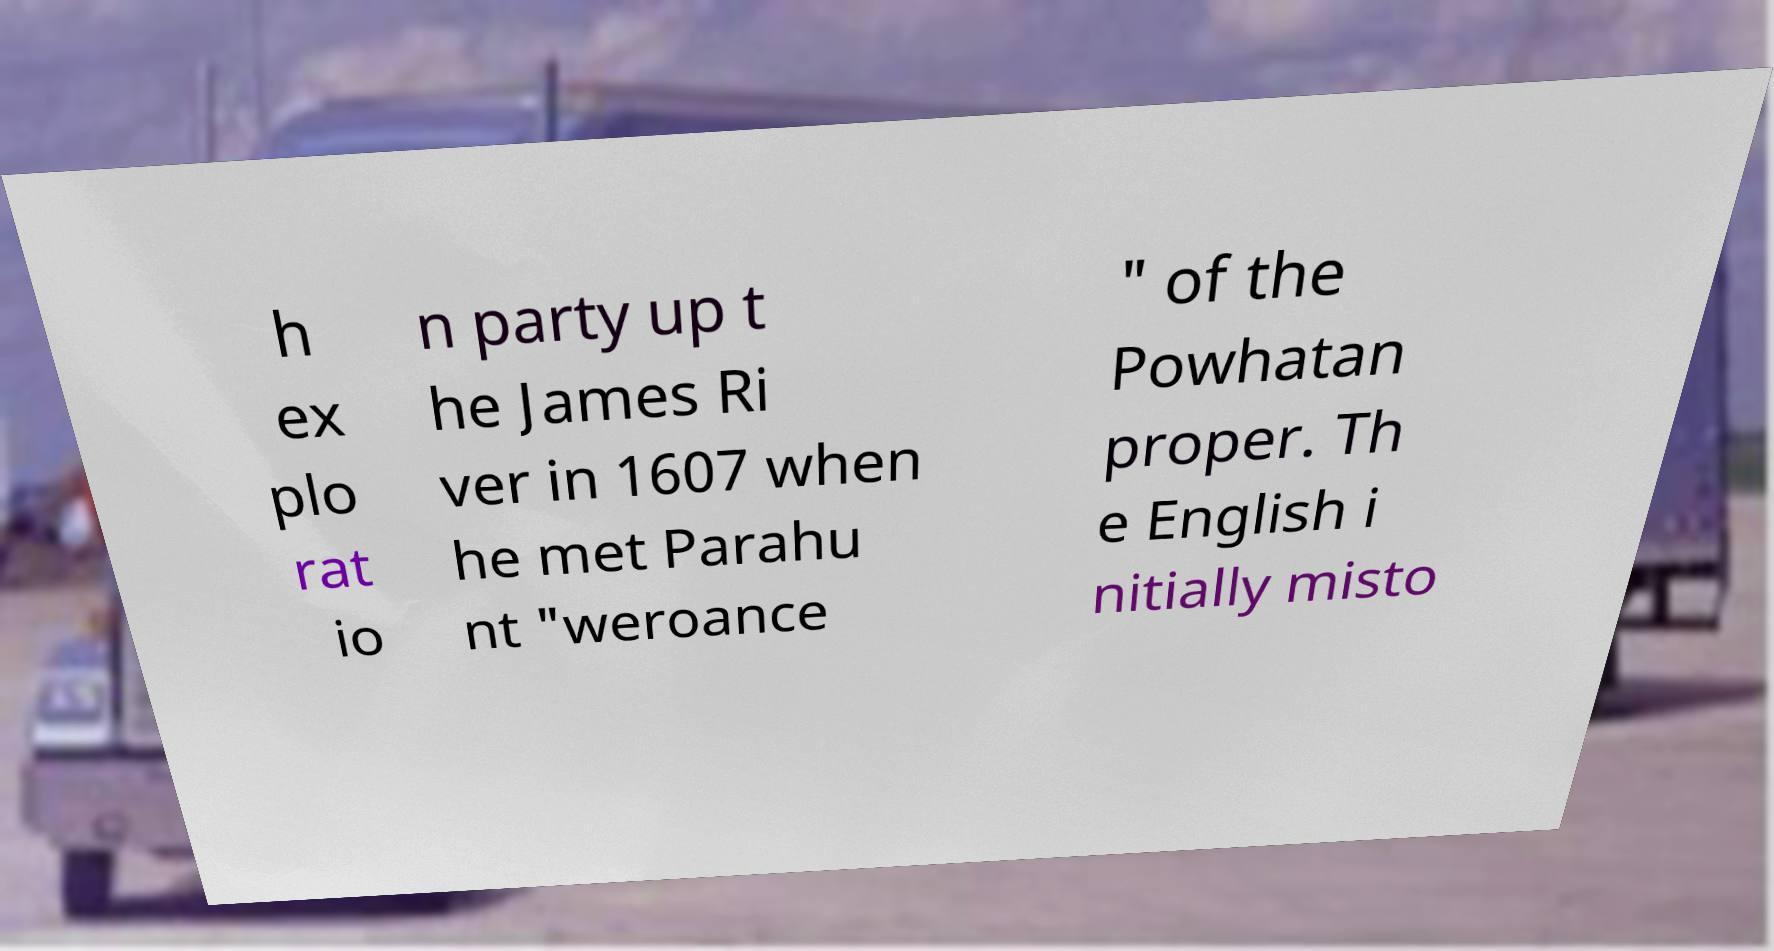Please read and relay the text visible in this image. What does it say? h ex plo rat io n party up t he James Ri ver in 1607 when he met Parahu nt "weroance " of the Powhatan proper. Th e English i nitially misto 